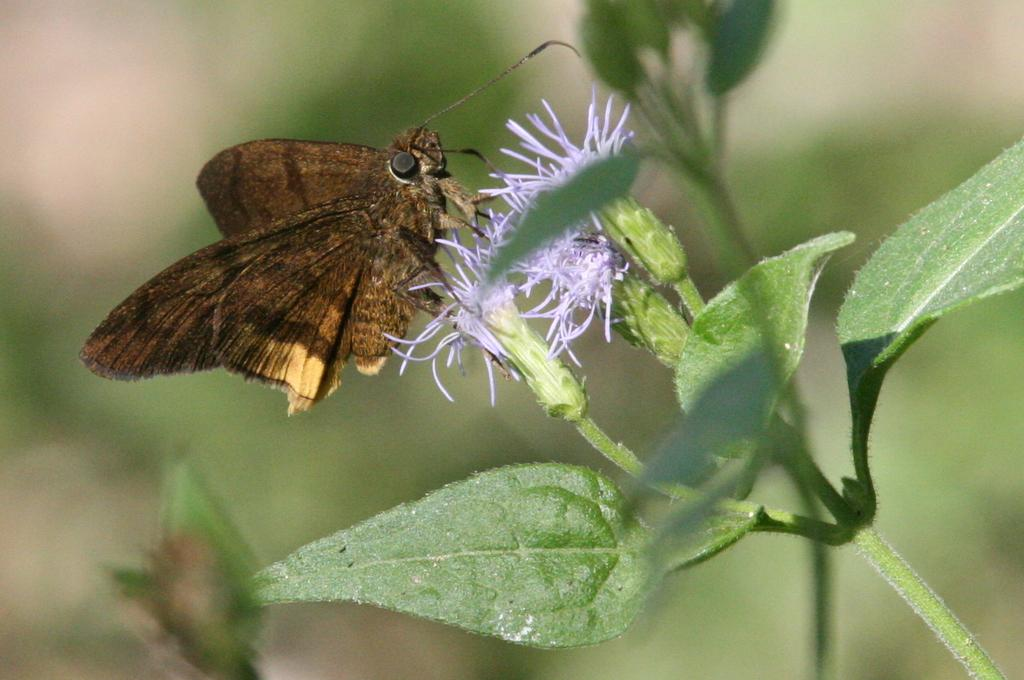What is the main subject in the center of the image? There is a fly in the center of the image. What is the fly located on in the image? The fly is on a plant. What type of thunder can be heard coming from the fly in the image? There is no thunder present in the image, as it features a fly on a plant. What type of lumber is the fly using to build its nest in the image? There is no lumber present in the image, nor is there any indication that the fly is building a nest. 